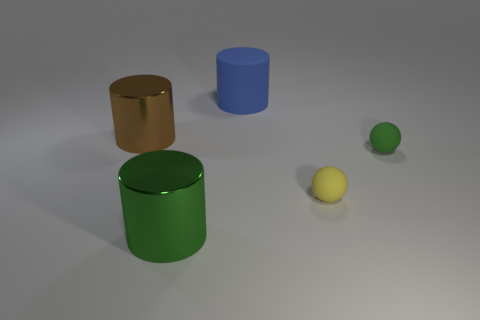Is the shape of the yellow thing the same as the green matte thing?
Offer a terse response. Yes. What material is the small green object?
Provide a succinct answer. Rubber. How many big objects are in front of the small green object and behind the large brown metal cylinder?
Provide a succinct answer. 0. Is the yellow matte thing the same size as the brown cylinder?
Keep it short and to the point. No. Is the size of the green object left of the blue object the same as the large blue thing?
Offer a very short reply. Yes. There is a big cylinder behind the brown metal cylinder; what color is it?
Offer a terse response. Blue. How many tiny matte things are there?
Give a very brief answer. 2. There is a big blue thing that is the same material as the yellow sphere; what is its shape?
Keep it short and to the point. Cylinder. Does the metal thing in front of the brown thing have the same color as the small matte object right of the small yellow thing?
Provide a short and direct response. Yes. Is the number of green shiny cylinders that are to the right of the large blue matte object the same as the number of tiny spheres?
Keep it short and to the point. No. 